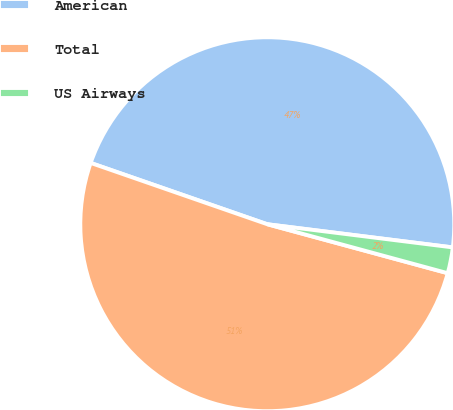Convert chart. <chart><loc_0><loc_0><loc_500><loc_500><pie_chart><fcel>American<fcel>Total<fcel>US Airways<nl><fcel>46.66%<fcel>51.1%<fcel>2.24%<nl></chart> 